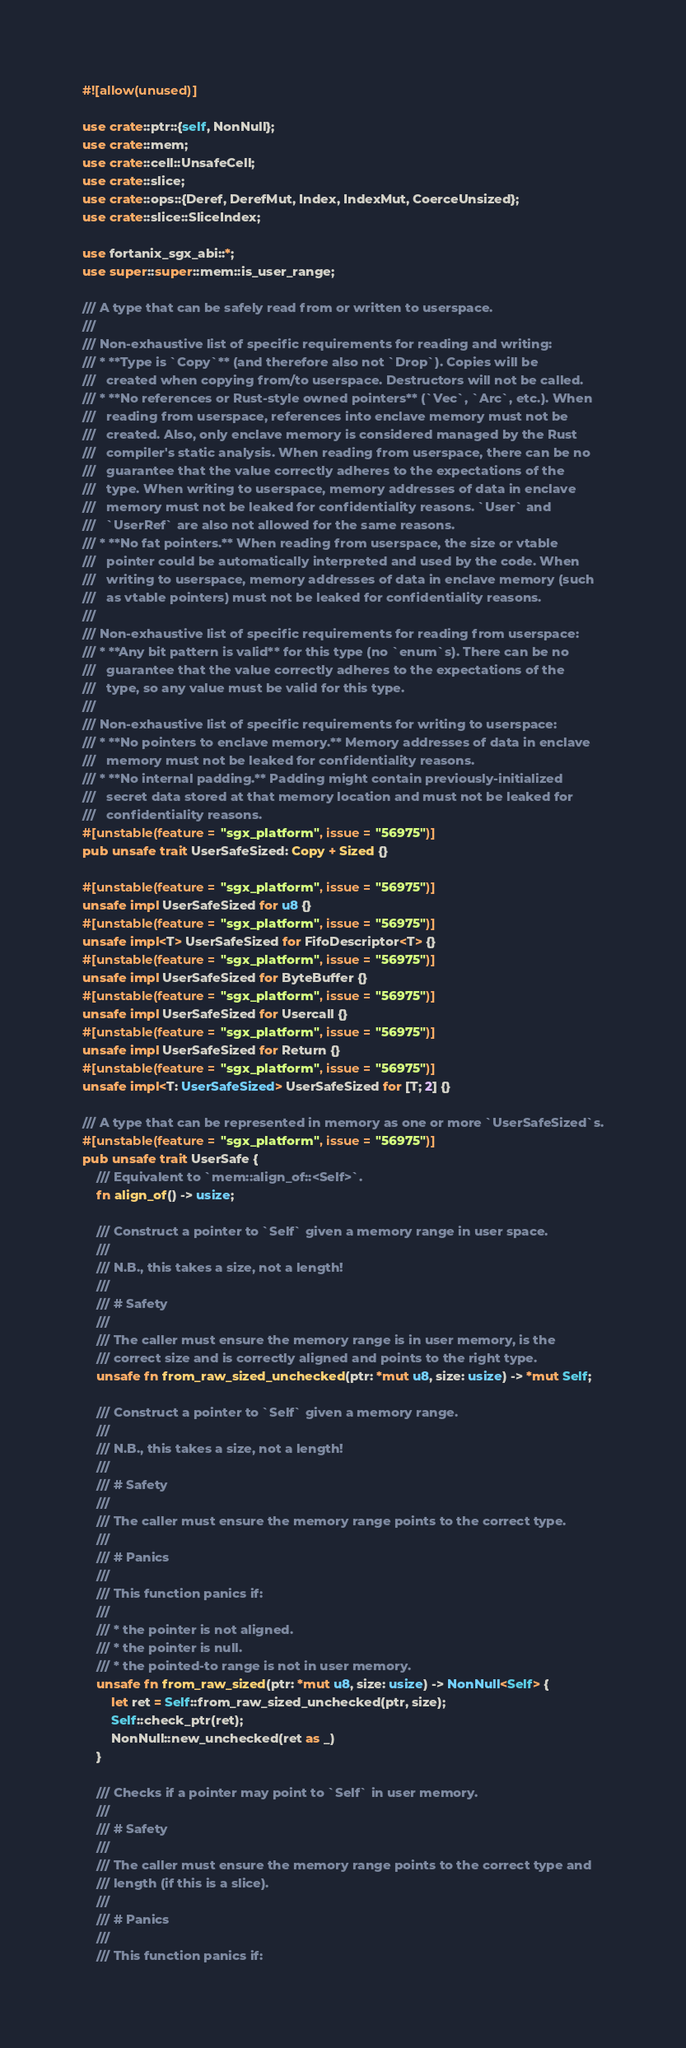<code> <loc_0><loc_0><loc_500><loc_500><_Rust_>#![allow(unused)]

use crate::ptr::{self, NonNull};
use crate::mem;
use crate::cell::UnsafeCell;
use crate::slice;
use crate::ops::{Deref, DerefMut, Index, IndexMut, CoerceUnsized};
use crate::slice::SliceIndex;

use fortanix_sgx_abi::*;
use super::super::mem::is_user_range;

/// A type that can be safely read from or written to userspace.
///
/// Non-exhaustive list of specific requirements for reading and writing:
/// * **Type is `Copy`** (and therefore also not `Drop`). Copies will be
///   created when copying from/to userspace. Destructors will not be called.
/// * **No references or Rust-style owned pointers** (`Vec`, `Arc`, etc.). When
///   reading from userspace, references into enclave memory must not be
///   created. Also, only enclave memory is considered managed by the Rust
///   compiler's static analysis. When reading from userspace, there can be no
///   guarantee that the value correctly adheres to the expectations of the
///   type. When writing to userspace, memory addresses of data in enclave
///   memory must not be leaked for confidentiality reasons. `User` and
///   `UserRef` are also not allowed for the same reasons.
/// * **No fat pointers.** When reading from userspace, the size or vtable
///   pointer could be automatically interpreted and used by the code. When
///   writing to userspace, memory addresses of data in enclave memory (such
///   as vtable pointers) must not be leaked for confidentiality reasons.
///
/// Non-exhaustive list of specific requirements for reading from userspace:
/// * **Any bit pattern is valid** for this type (no `enum`s). There can be no
///   guarantee that the value correctly adheres to the expectations of the
///   type, so any value must be valid for this type.
///
/// Non-exhaustive list of specific requirements for writing to userspace:
/// * **No pointers to enclave memory.** Memory addresses of data in enclave
///   memory must not be leaked for confidentiality reasons.
/// * **No internal padding.** Padding might contain previously-initialized
///   secret data stored at that memory location and must not be leaked for
///   confidentiality reasons.
#[unstable(feature = "sgx_platform", issue = "56975")]
pub unsafe trait UserSafeSized: Copy + Sized {}

#[unstable(feature = "sgx_platform", issue = "56975")]
unsafe impl UserSafeSized for u8 {}
#[unstable(feature = "sgx_platform", issue = "56975")]
unsafe impl<T> UserSafeSized for FifoDescriptor<T> {}
#[unstable(feature = "sgx_platform", issue = "56975")]
unsafe impl UserSafeSized for ByteBuffer {}
#[unstable(feature = "sgx_platform", issue = "56975")]
unsafe impl UserSafeSized for Usercall {}
#[unstable(feature = "sgx_platform", issue = "56975")]
unsafe impl UserSafeSized for Return {}
#[unstable(feature = "sgx_platform", issue = "56975")]
unsafe impl<T: UserSafeSized> UserSafeSized for [T; 2] {}

/// A type that can be represented in memory as one or more `UserSafeSized`s.
#[unstable(feature = "sgx_platform", issue = "56975")]
pub unsafe trait UserSafe {
    /// Equivalent to `mem::align_of::<Self>`.
    fn align_of() -> usize;

    /// Construct a pointer to `Self` given a memory range in user space.
    ///
    /// N.B., this takes a size, not a length!
    ///
    /// # Safety
    ///
    /// The caller must ensure the memory range is in user memory, is the
    /// correct size and is correctly aligned and points to the right type.
    unsafe fn from_raw_sized_unchecked(ptr: *mut u8, size: usize) -> *mut Self;

    /// Construct a pointer to `Self` given a memory range.
    ///
    /// N.B., this takes a size, not a length!
    ///
    /// # Safety
    ///
    /// The caller must ensure the memory range points to the correct type.
    ///
    /// # Panics
    ///
    /// This function panics if:
    ///
    /// * the pointer is not aligned.
    /// * the pointer is null.
    /// * the pointed-to range is not in user memory.
    unsafe fn from_raw_sized(ptr: *mut u8, size: usize) -> NonNull<Self> {
        let ret = Self::from_raw_sized_unchecked(ptr, size);
        Self::check_ptr(ret);
        NonNull::new_unchecked(ret as _)
    }

    /// Checks if a pointer may point to `Self` in user memory.
    ///
    /// # Safety
    ///
    /// The caller must ensure the memory range points to the correct type and
    /// length (if this is a slice).
    ///
    /// # Panics
    ///
    /// This function panics if:</code> 